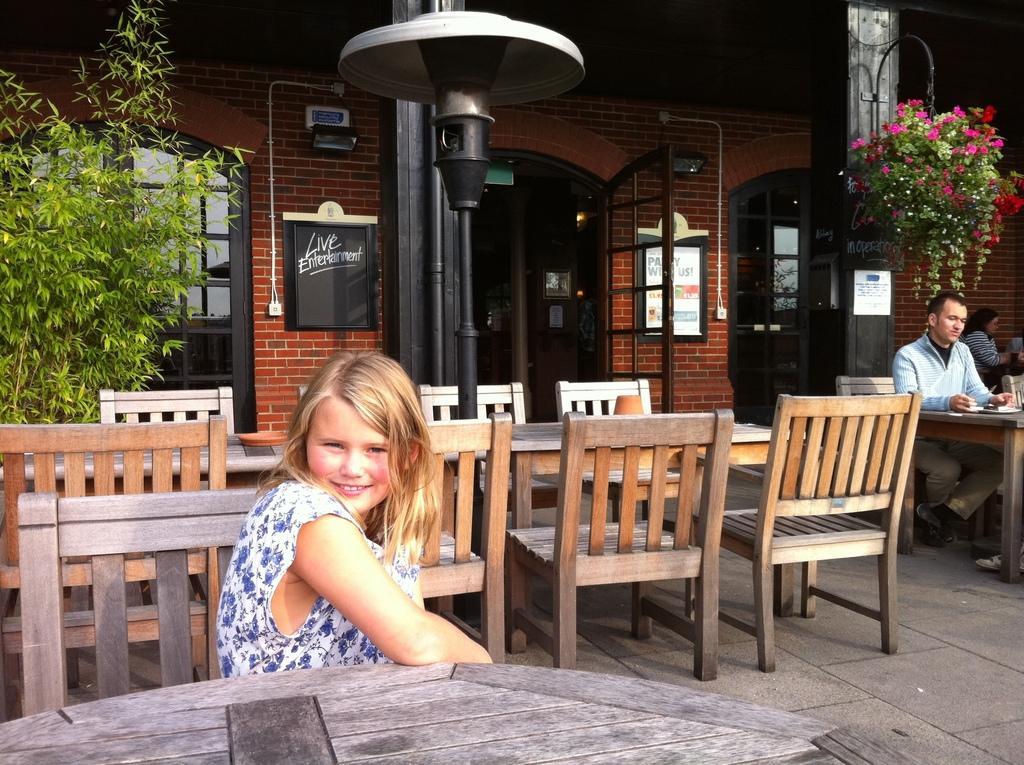Describe this image in one or two sentences. In this picture we can see one woman is sitting in front of a table, on right side of the picture there is a man sitting in front of table and looking at the plates in the background we can see brick wall and glass doors there are some plants holding to the pole, on the left side we can see some plants, on the backside of women there is a table and some of the chairs here. 